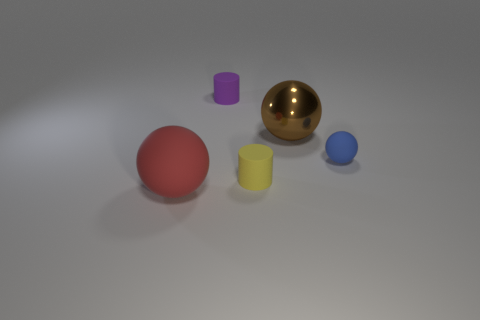Are there any brown rubber objects that have the same shape as the purple object? After examining the image, it appears that there are no brown rubber objects present at all. The items in view consist of a purple cylinder, a golden sphere, a red sphere, a yellow cylinder, and a blue sphere. None of these objects match the description of being a brown rubber object with the same shape as the purple cylinder. 